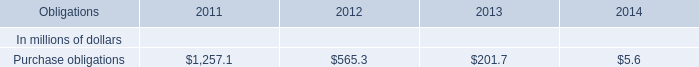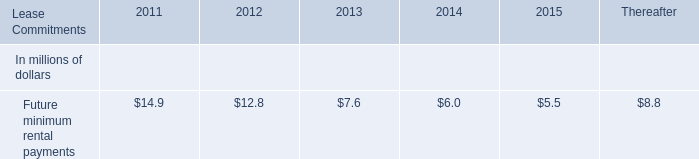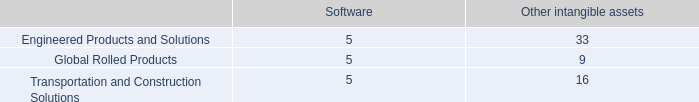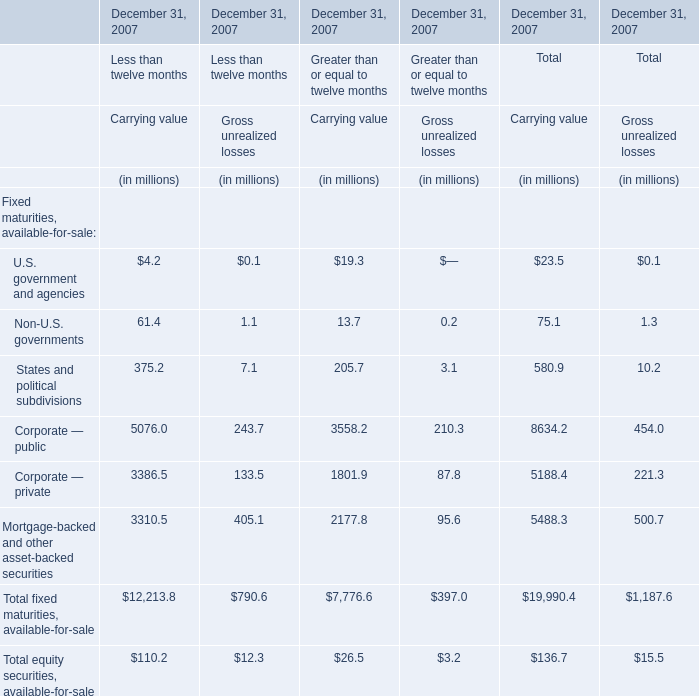What is the sum of States and political subdivisions of Carrying value for Less than twelve months in 2007 and Purchase obligations in 2012? (in million) 
Computations: (375.2 + 565.3)
Answer: 940.5. 